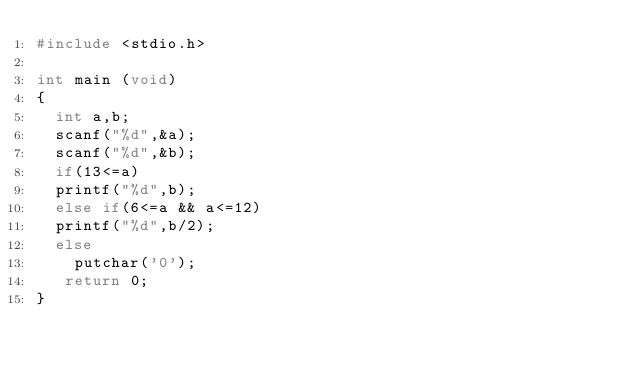<code> <loc_0><loc_0><loc_500><loc_500><_C_>#include <stdio.h>

int main (void)
{
  int a,b;
  scanf("%d",&a);
  scanf("%d",&b);
  if(13<=a)
	printf("%d",b);
  else if(6<=a && a<=12)
	printf("%d",b/2);
  else
	  putchar('0');
   return 0;
}
</code> 